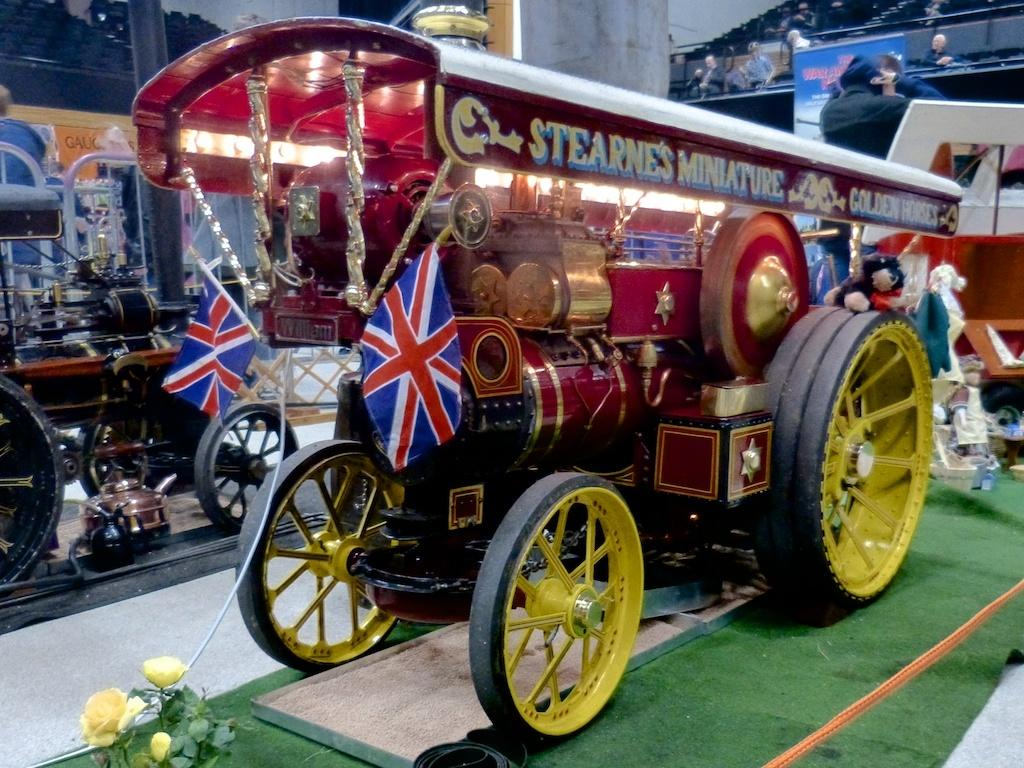What types of objects are present in the image? There are vehicles and flowers in the image. What is the color of the carpet in the image? The carpet in the image is green. Can you describe the person in the image? There is a person in the image. What else can be seen in the background of the image? There are other objects in the background of the image. What type of cake is being served by the secretary in the image? There is no secretary or cake present in the image. How does the person in the image plan to wash the vehicles? There is no indication in the image that the person is planning to wash the vehicles. 